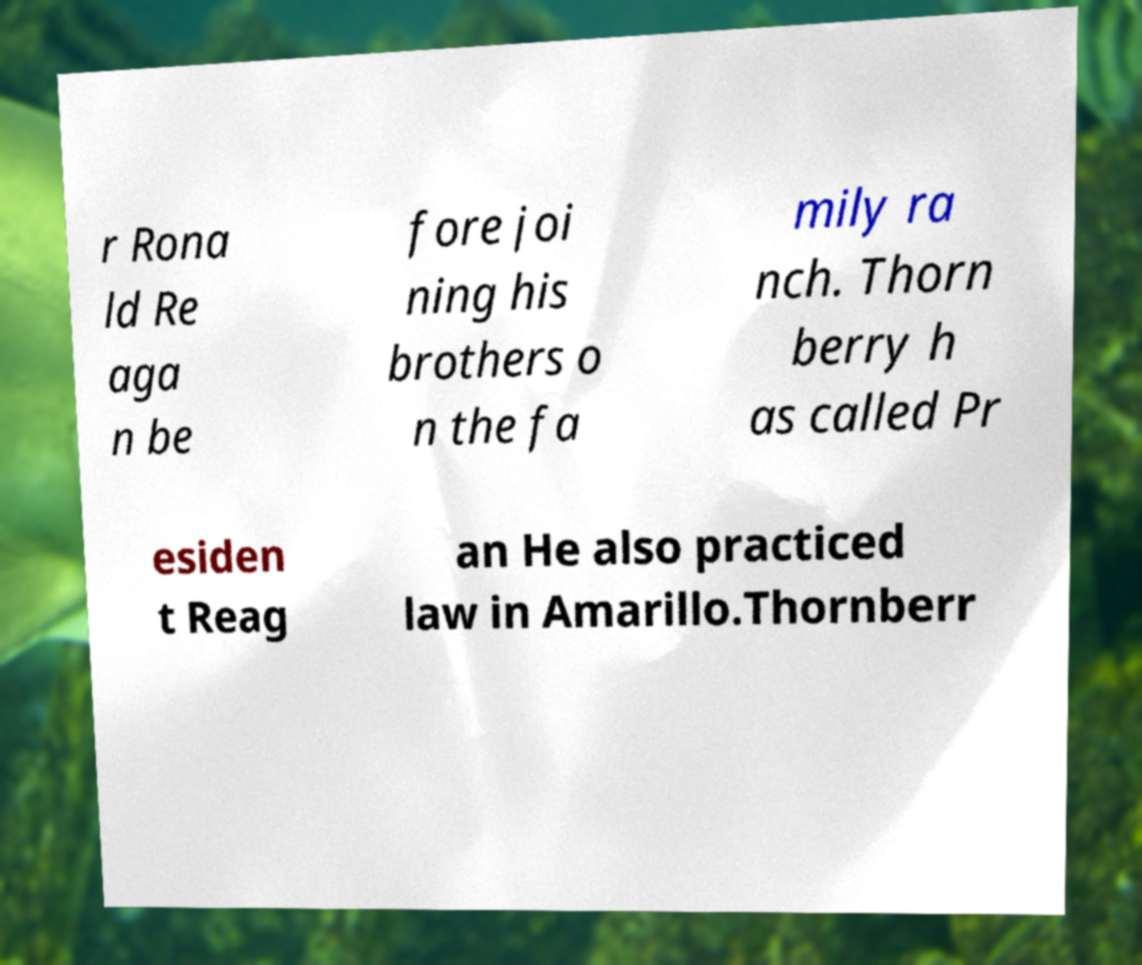Could you assist in decoding the text presented in this image and type it out clearly? r Rona ld Re aga n be fore joi ning his brothers o n the fa mily ra nch. Thorn berry h as called Pr esiden t Reag an He also practiced law in Amarillo.Thornberr 